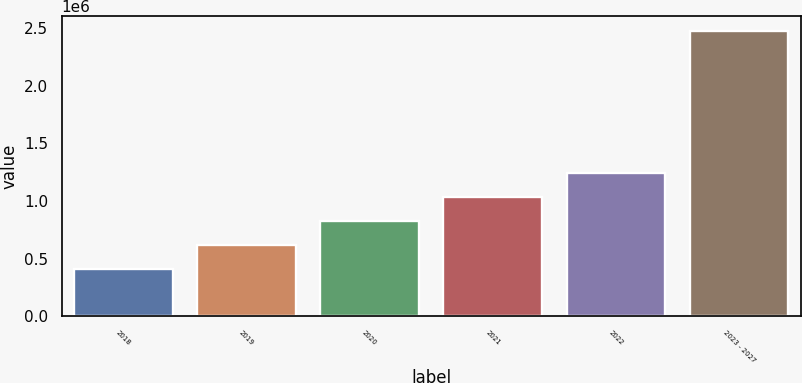Convert chart. <chart><loc_0><loc_0><loc_500><loc_500><bar_chart><fcel>2018<fcel>2019<fcel>2020<fcel>2021<fcel>2022<fcel>2023 - 2027<nl><fcel>412057<fcel>618747<fcel>825437<fcel>1.03213e+06<fcel>1.23882e+06<fcel>2.47896e+06<nl></chart> 